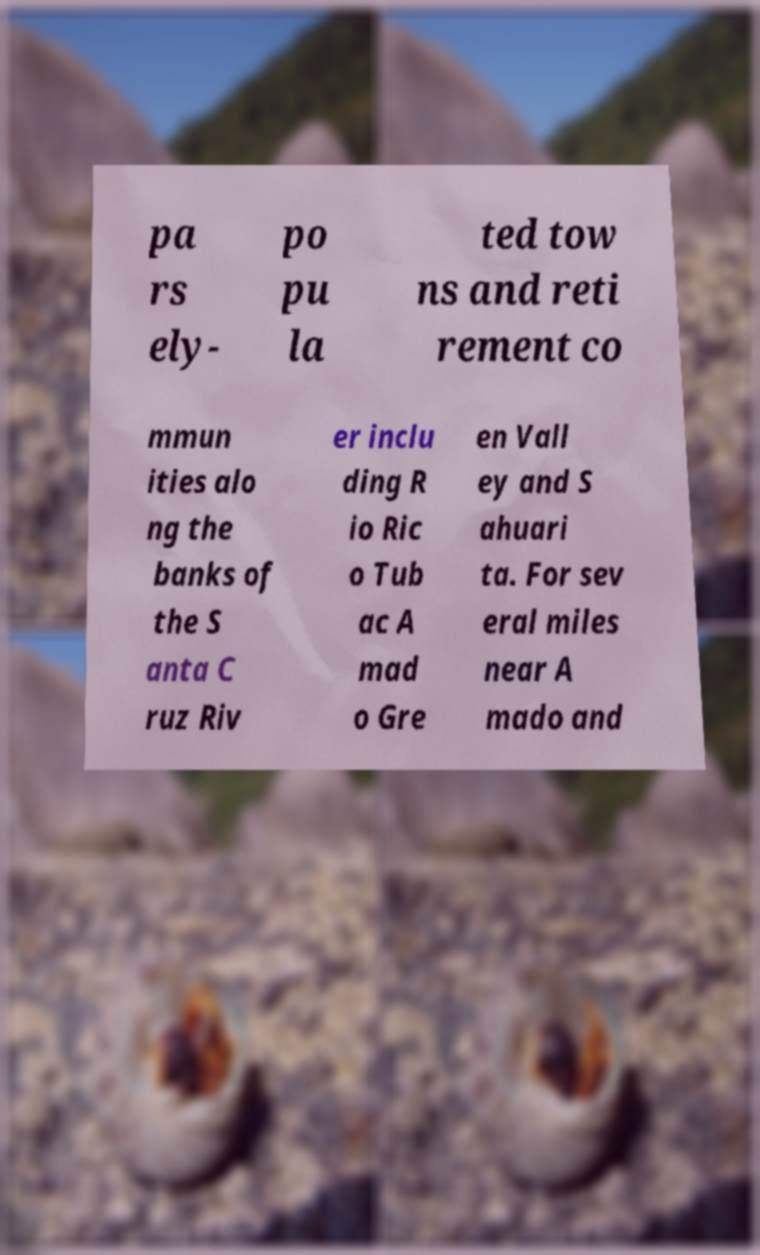Could you extract and type out the text from this image? pa rs ely- po pu la ted tow ns and reti rement co mmun ities alo ng the banks of the S anta C ruz Riv er inclu ding R io Ric o Tub ac A mad o Gre en Vall ey and S ahuari ta. For sev eral miles near A mado and 